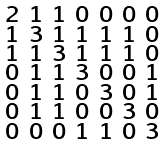Convert formula to latex. <formula><loc_0><loc_0><loc_500><loc_500>\begin{smallmatrix} 2 & 1 & 1 & 0 & 0 & 0 & 0 \\ 1 & 3 & 1 & 1 & 1 & 1 & 0 \\ 1 & 1 & 3 & 1 & 1 & 1 & 0 \\ 0 & 1 & 1 & 3 & 0 & 0 & 1 \\ 0 & 1 & 1 & 0 & 3 & 0 & 1 \\ 0 & 1 & 1 & 0 & 0 & 3 & 0 \\ 0 & 0 & 0 & 1 & 1 & 0 & 3 \end{smallmatrix}</formula> 